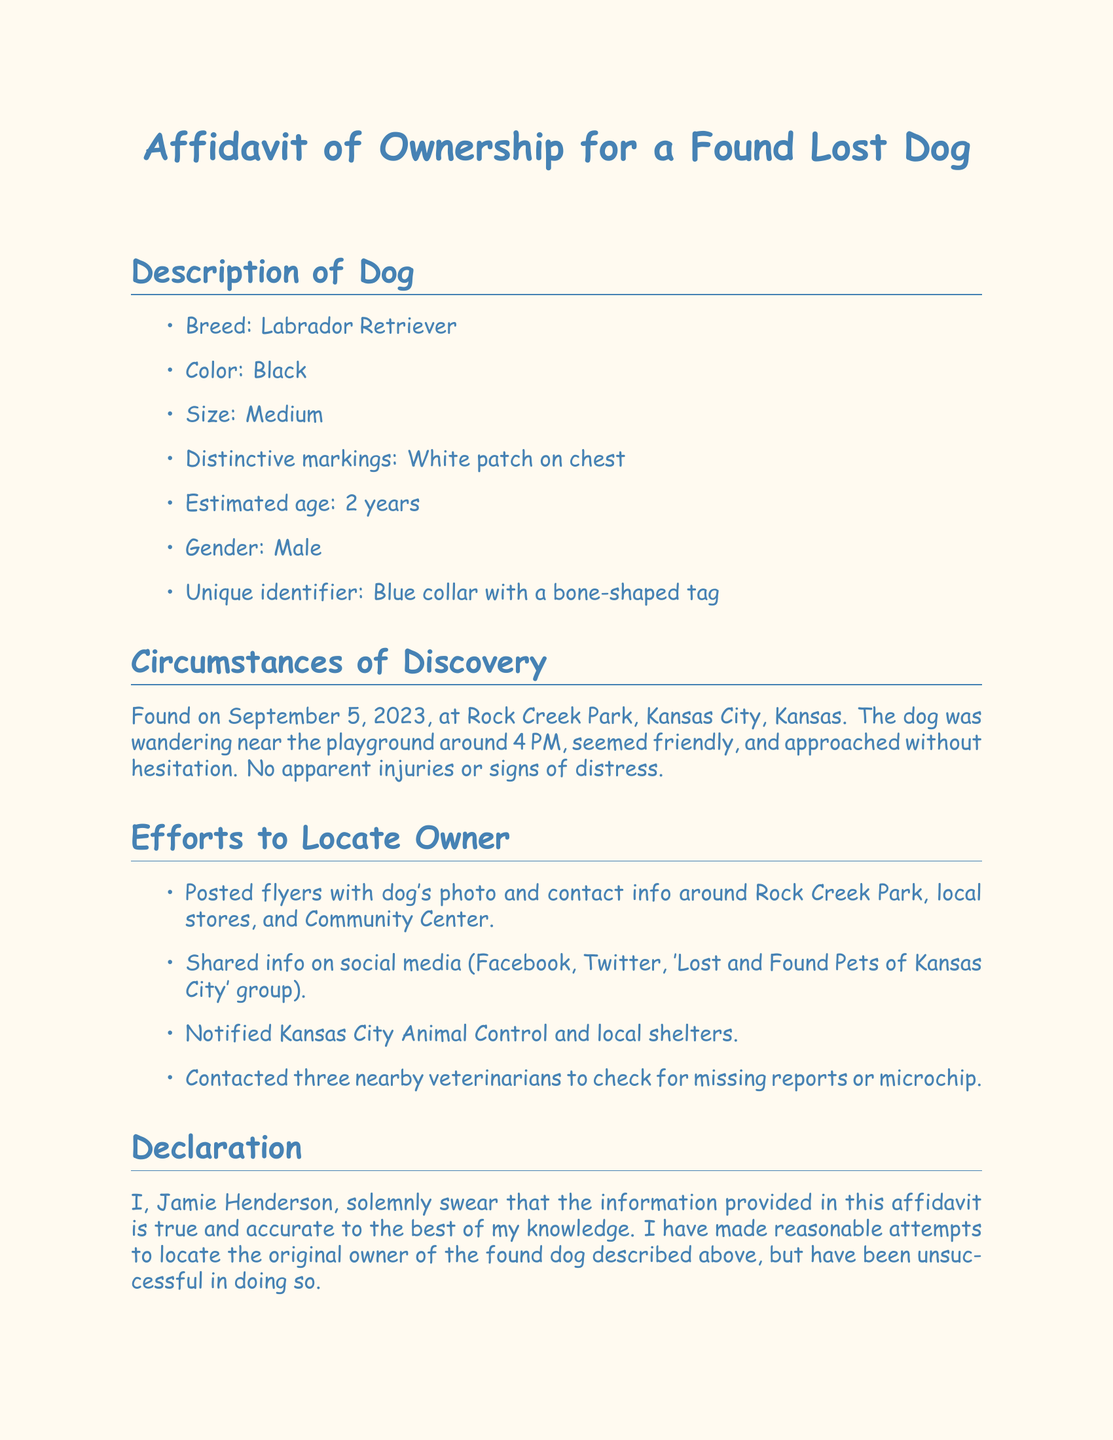What is the breed of the dog? The document specifies the breed of the dog in the description section.
Answer: Labrador Retriever What color is the dog? The dog's color is mentioned in the description section of the document.
Answer: Black When was the dog found? The document states the date when the dog was found in the circumstances of discovery section.
Answer: September 5, 2023 Where was the dog found? The location where the dog was discovered is indicated in the circumstances of discovery section.
Answer: Rock Creek Park, Kansas City, Kansas What is the dog's estimated age? The estimated age of the dog is provided in the description section of the document.
Answer: 2 years What efforts were made to locate the owner? The document lists specific actions taken to find the dog's owner under the efforts to locate owner section.
Answer: Posted flyers Who is the declarant? The declarant's name is stated at the end of the document.
Answer: Jamie Henderson What is the declarant's email? The email of the declarant is provided in the declarant information section.
Answer: jamie.henderson@example.com What unique identifier does the dog have? The unique identifier of the dog is mentioned in the description section.
Answer: Blue collar with a bone-shaped tag 